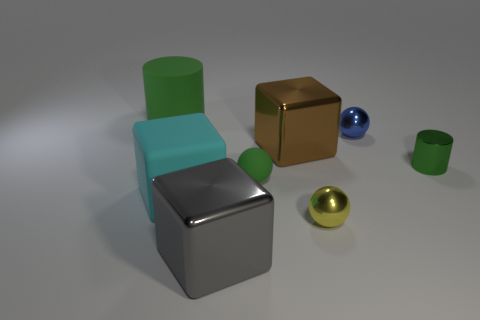There is a ball that is the same color as the tiny metallic cylinder; what size is it?
Your answer should be compact. Small. What is the size of the green object that is the same material as the small yellow object?
Your answer should be compact. Small. The brown block has what size?
Make the answer very short. Large. What shape is the gray metallic thing?
Provide a succinct answer. Cube. There is a thing that is on the right side of the blue metal ball; does it have the same color as the big rubber cylinder?
Your answer should be compact. Yes. What size is the green object that is the same shape as the yellow metallic object?
Provide a short and direct response. Small. Is there a small yellow ball in front of the brown shiny thing that is right of the large block that is left of the gray thing?
Keep it short and to the point. Yes. What is the green cylinder that is on the left side of the small green matte sphere made of?
Provide a succinct answer. Rubber. What number of big things are either green metal objects or green matte cylinders?
Ensure brevity in your answer.  1. Is the size of the green object left of the gray shiny cube the same as the green ball?
Offer a very short reply. No. 